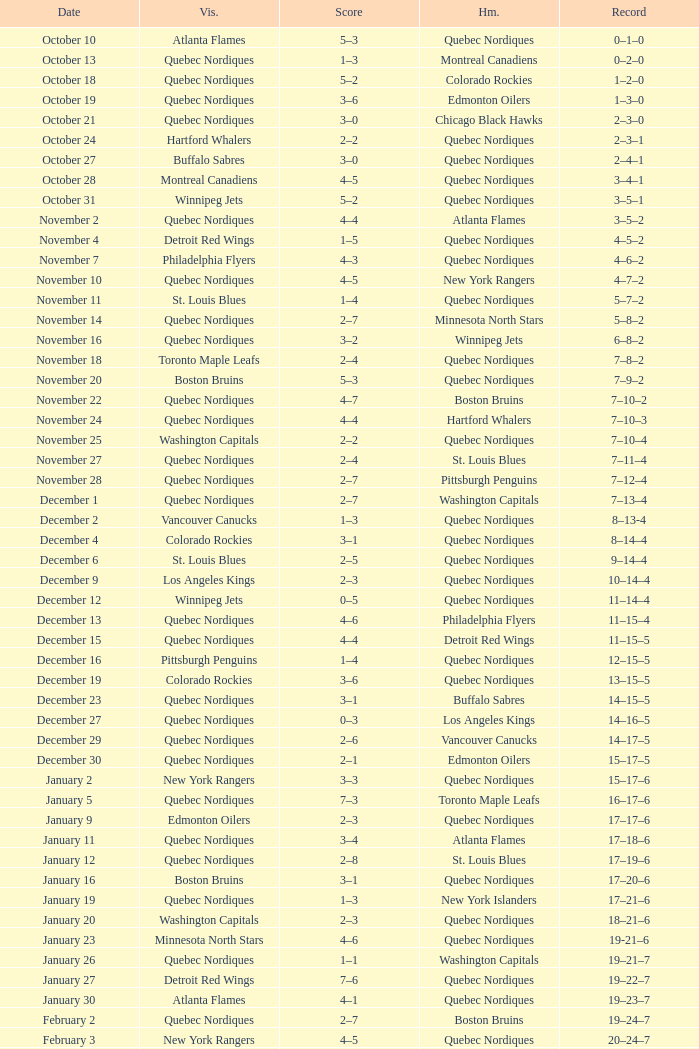Which Home has a Record of 16–17–6? Toronto Maple Leafs. 